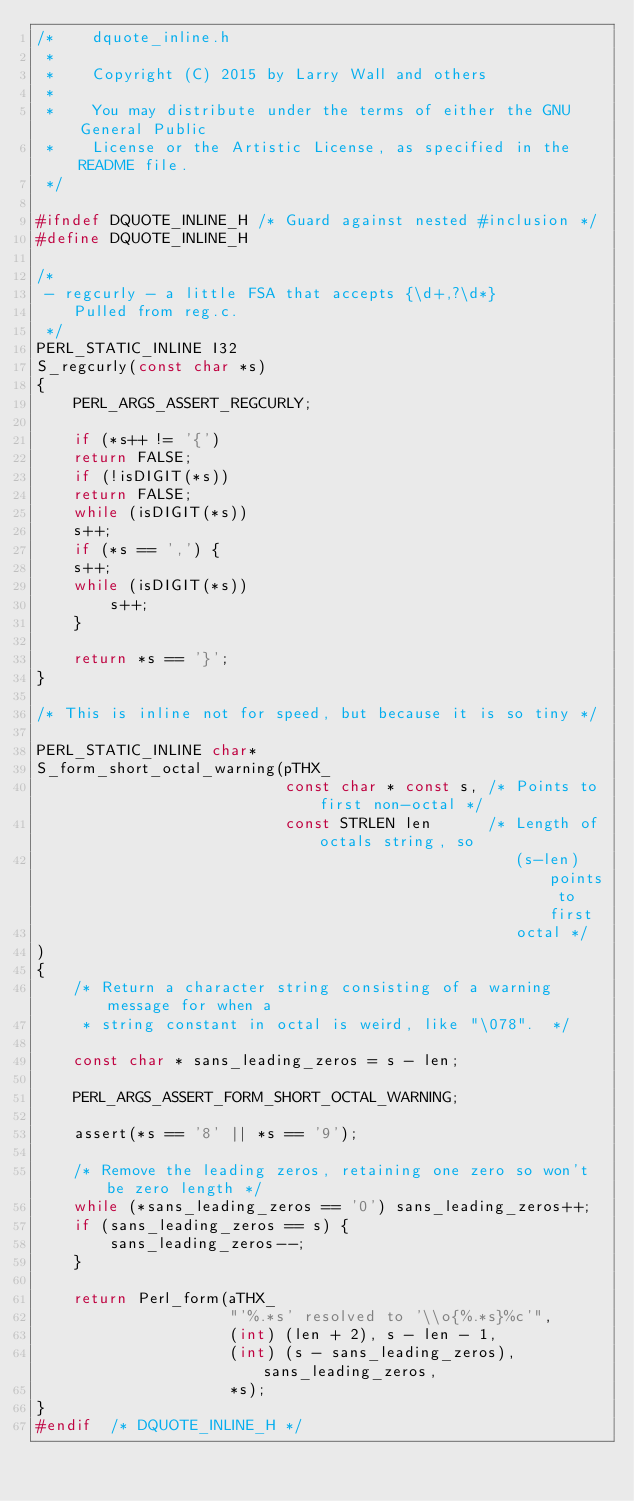<code> <loc_0><loc_0><loc_500><loc_500><_C_>/*    dquote_inline.h
 *
 *    Copyright (C) 2015 by Larry Wall and others
 *
 *    You may distribute under the terms of either the GNU General Public
 *    License or the Artistic License, as specified in the README file.
 */

#ifndef DQUOTE_INLINE_H /* Guard against nested #inclusion */
#define DQUOTE_INLINE_H

/*
 - regcurly - a little FSA that accepts {\d+,?\d*}
    Pulled from reg.c.
 */
PERL_STATIC_INLINE I32
S_regcurly(const char *s)
{
    PERL_ARGS_ASSERT_REGCURLY;

    if (*s++ != '{')
	return FALSE;
    if (!isDIGIT(*s))
	return FALSE;
    while (isDIGIT(*s))
	s++;
    if (*s == ',') {
	s++;
	while (isDIGIT(*s))
	    s++;
    }

    return *s == '}';
}

/* This is inline not for speed, but because it is so tiny */

PERL_STATIC_INLINE char*
S_form_short_octal_warning(pTHX_
                           const char * const s, /* Points to first non-octal */
                           const STRLEN len      /* Length of octals string, so
                                                    (s-len) points to first
                                                    octal */
)
{
    /* Return a character string consisting of a warning message for when a
     * string constant in octal is weird, like "\078".  */

    const char * sans_leading_zeros = s - len;

    PERL_ARGS_ASSERT_FORM_SHORT_OCTAL_WARNING;

    assert(*s == '8' || *s == '9');

    /* Remove the leading zeros, retaining one zero so won't be zero length */
    while (*sans_leading_zeros == '0') sans_leading_zeros++;
    if (sans_leading_zeros == s) {
        sans_leading_zeros--;
    }

    return Perl_form(aTHX_
                     "'%.*s' resolved to '\\o{%.*s}%c'",
                     (int) (len + 2), s - len - 1,
                     (int) (s - sans_leading_zeros), sans_leading_zeros,
                     *s);
}
#endif  /* DQUOTE_INLINE_H */
</code> 